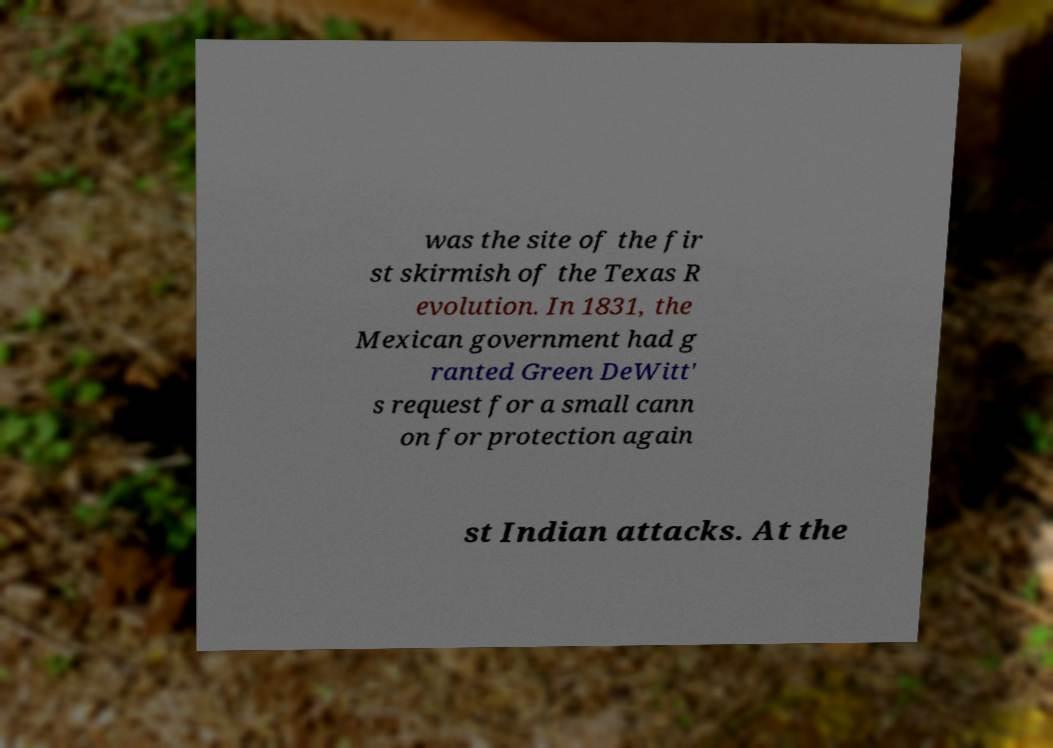Can you read and provide the text displayed in the image?This photo seems to have some interesting text. Can you extract and type it out for me? was the site of the fir st skirmish of the Texas R evolution. In 1831, the Mexican government had g ranted Green DeWitt' s request for a small cann on for protection again st Indian attacks. At the 